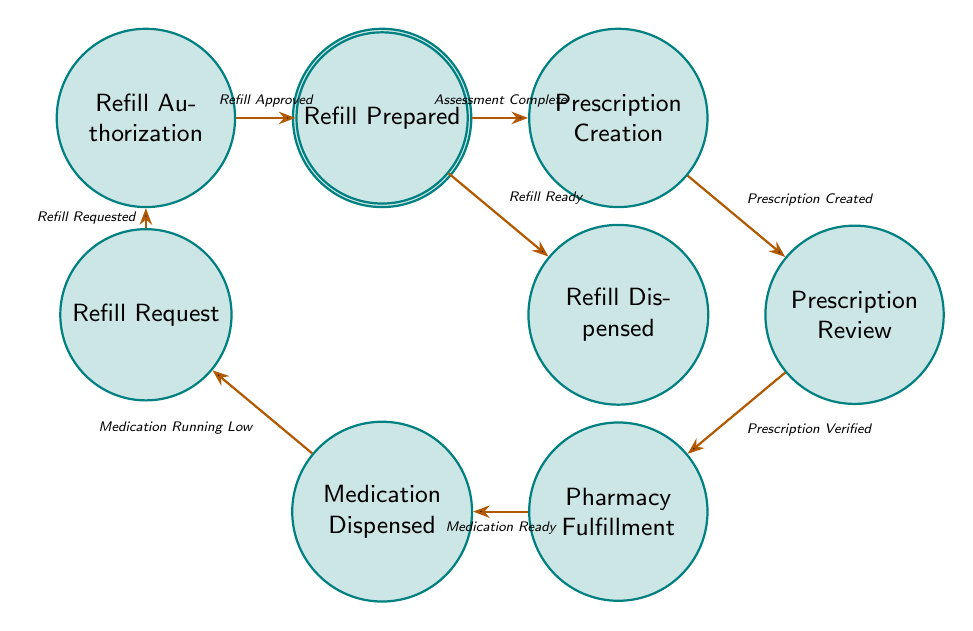What is the first state in the medication management workflow? The diagram shows that the first state is Patient Consultation, where the doctor consults with the patient to assess their medication needs.
Answer: Patient Consultation How many total states are there in the diagram? By counting each state listed in the diagram, there are nine distinct states in total related to the medication management and refill workflow.
Answer: Nine What triggers the transition from Prescription Review to Pharmacy Fulfillment? The transition from Prescription Review to Pharmacy Fulfillment occurs when the trigger Prescription Verified is acted upon, indicating that the patient has verified the prescription's accuracy.
Answer: Prescription Verified What is the final state in the refill process? Following the final transition in the process, the last state in the refill workflow is Refill Dispensed, where the pharmacy dispenses the medication refill to the patient.
Answer: Refill Dispensed What is the relationship between Refill Request and Refill Authorization? The transition flows from Refill Request to Refill Authorization, triggered by Refill Requested, showing that after a refill request is made, it must be authorized by the doctor.
Answer: Transition flow How does a patient indicate that their medication is running low? The diagram indicates this situation as a transition from Medication Dispensed to Refill Request, which is triggered by the event Medication Running Low.
Answer: Medication Running Low What action follows after the doctor approves a refill? After the doctor authorizes the refill request, the next action in the workflow is Refill Prepared, indicating that the pharmacy prepares the medication refill.
Answer: Refill Prepared How many transitions are there in the workflow? By counting the lines connecting the states, you can identify that there are eight transitions that describe the movement between the states in the workflow.
Answer: Eight What occurs immediately after a prescription is created? Immediately following the creation of a prescription, the workflow transitions to Prescription Review, where the patient reviews the accuracy and completeness of the prescription.
Answer: Prescription Review 